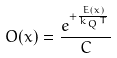Convert formula to latex. <formula><loc_0><loc_0><loc_500><loc_500>O ( x ) = \frac { e ^ { + \frac { E ( x ) } { k _ { Q } T } } } { C }</formula> 